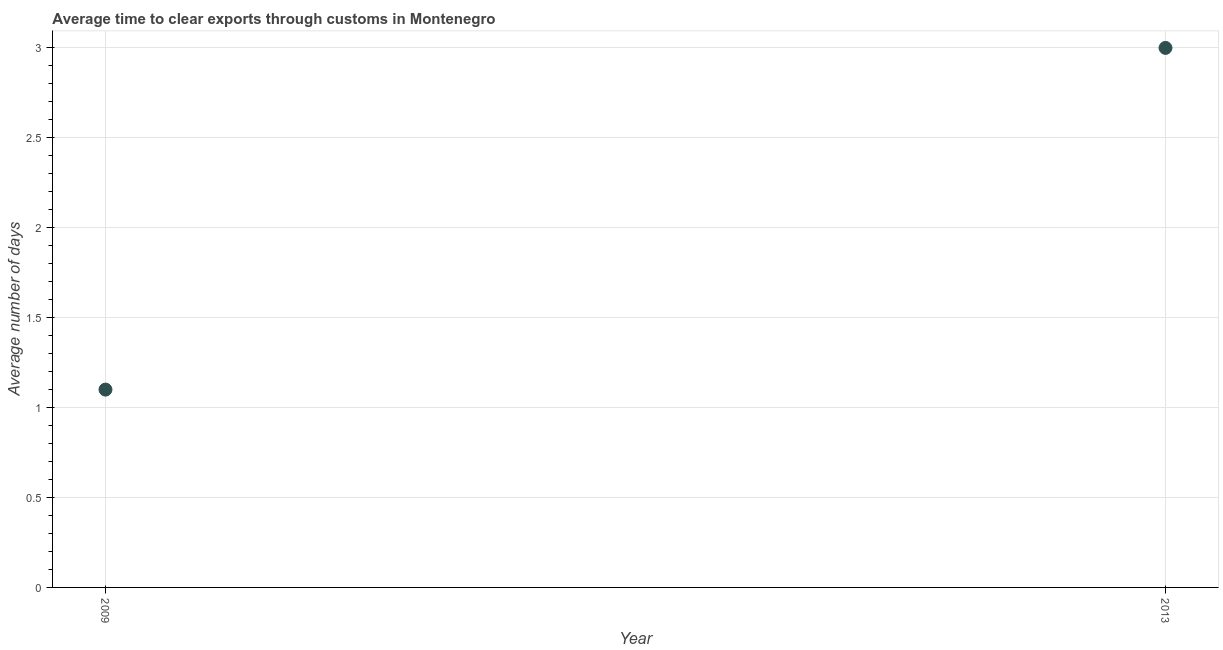What is the time to clear exports through customs in 2013?
Your answer should be compact. 3. Across all years, what is the maximum time to clear exports through customs?
Your answer should be very brief. 3. In which year was the time to clear exports through customs maximum?
Your response must be concise. 2013. In which year was the time to clear exports through customs minimum?
Make the answer very short. 2009. What is the sum of the time to clear exports through customs?
Provide a short and direct response. 4.1. What is the difference between the time to clear exports through customs in 2009 and 2013?
Offer a terse response. -1.9. What is the average time to clear exports through customs per year?
Provide a succinct answer. 2.05. What is the median time to clear exports through customs?
Ensure brevity in your answer.  2.05. Do a majority of the years between 2009 and 2013 (inclusive) have time to clear exports through customs greater than 1.8 days?
Offer a terse response. No. What is the ratio of the time to clear exports through customs in 2009 to that in 2013?
Offer a very short reply. 0.37. Does the time to clear exports through customs monotonically increase over the years?
Provide a short and direct response. Yes. Are the values on the major ticks of Y-axis written in scientific E-notation?
Provide a succinct answer. No. Does the graph contain grids?
Make the answer very short. Yes. What is the title of the graph?
Keep it short and to the point. Average time to clear exports through customs in Montenegro. What is the label or title of the Y-axis?
Keep it short and to the point. Average number of days. What is the ratio of the Average number of days in 2009 to that in 2013?
Offer a terse response. 0.37. 